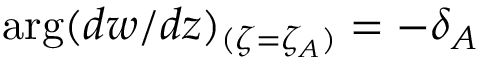Convert formula to latex. <formula><loc_0><loc_0><loc_500><loc_500>\arg ( d w / d z ) _ { ( \zeta = \zeta _ { A } ) } = - \delta _ { A }</formula> 